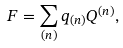<formula> <loc_0><loc_0><loc_500><loc_500>F = \sum _ { ( n ) } q _ { ( n ) } Q ^ { ( n ) } ,</formula> 